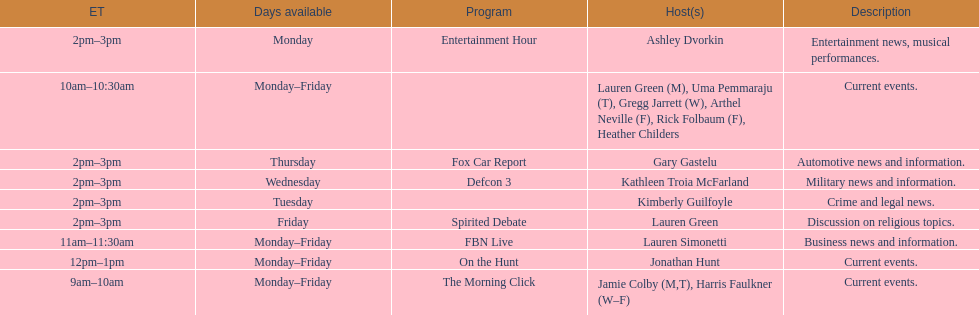Could you parse the entire table? {'header': ['ET', 'Days available', 'Program', 'Host(s)', 'Description'], 'rows': [['2pm–3pm', 'Monday', 'Entertainment Hour', 'Ashley Dvorkin', 'Entertainment news, musical performances.'], ['10am–10:30am', 'Monday–Friday', '', 'Lauren Green (M), Uma Pemmaraju (T), Gregg Jarrett (W), Arthel Neville (F), Rick Folbaum (F), Heather Childers', 'Current events.'], ['2pm–3pm', 'Thursday', 'Fox Car Report', 'Gary Gastelu', 'Automotive news and information.'], ['2pm–3pm', 'Wednesday', 'Defcon 3', 'Kathleen Troia McFarland', 'Military news and information.'], ['2pm–3pm', 'Tuesday', '', 'Kimberly Guilfoyle', 'Crime and legal news.'], ['2pm–3pm', 'Friday', 'Spirited Debate', 'Lauren Green', 'Discussion on religious topics.'], ['11am–11:30am', 'Monday–Friday', 'FBN Live', 'Lauren Simonetti', 'Business news and information.'], ['12pm–1pm', 'Monday–Friday', 'On the Hunt', 'Jonathan Hunt', 'Current events.'], ['9am–10am', 'Monday–Friday', 'The Morning Click', 'Jamie Colby (M,T), Harris Faulkner (W–F)', 'Current events.']]} Tell me the number of shows that only have one host per day. 7. 